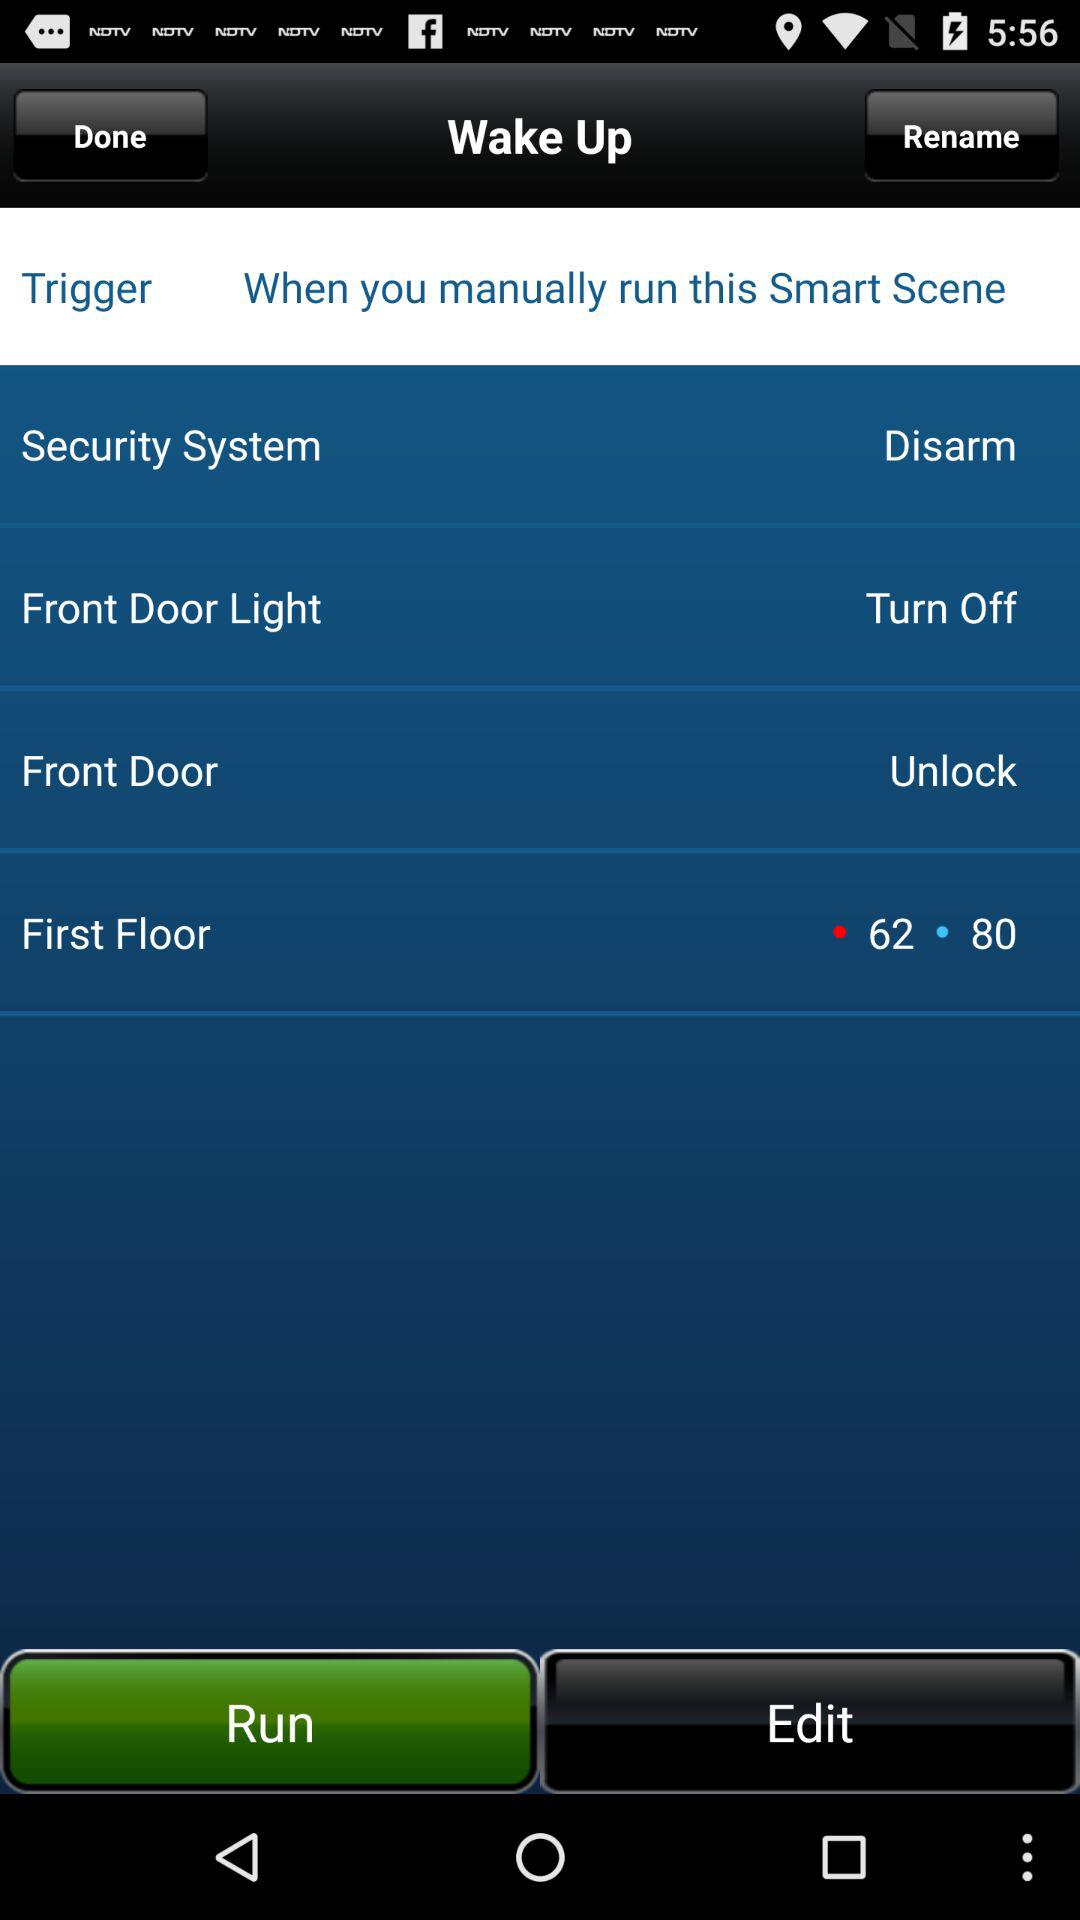How many actions are triggered by this smart scene?
Answer the question using a single word or phrase. 4 